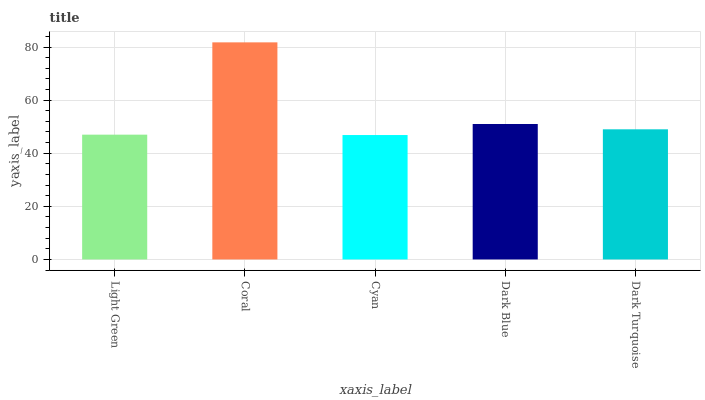Is Cyan the minimum?
Answer yes or no. Yes. Is Coral the maximum?
Answer yes or no. Yes. Is Coral the minimum?
Answer yes or no. No. Is Cyan the maximum?
Answer yes or no. No. Is Coral greater than Cyan?
Answer yes or no. Yes. Is Cyan less than Coral?
Answer yes or no. Yes. Is Cyan greater than Coral?
Answer yes or no. No. Is Coral less than Cyan?
Answer yes or no. No. Is Dark Turquoise the high median?
Answer yes or no. Yes. Is Dark Turquoise the low median?
Answer yes or no. Yes. Is Cyan the high median?
Answer yes or no. No. Is Dark Blue the low median?
Answer yes or no. No. 